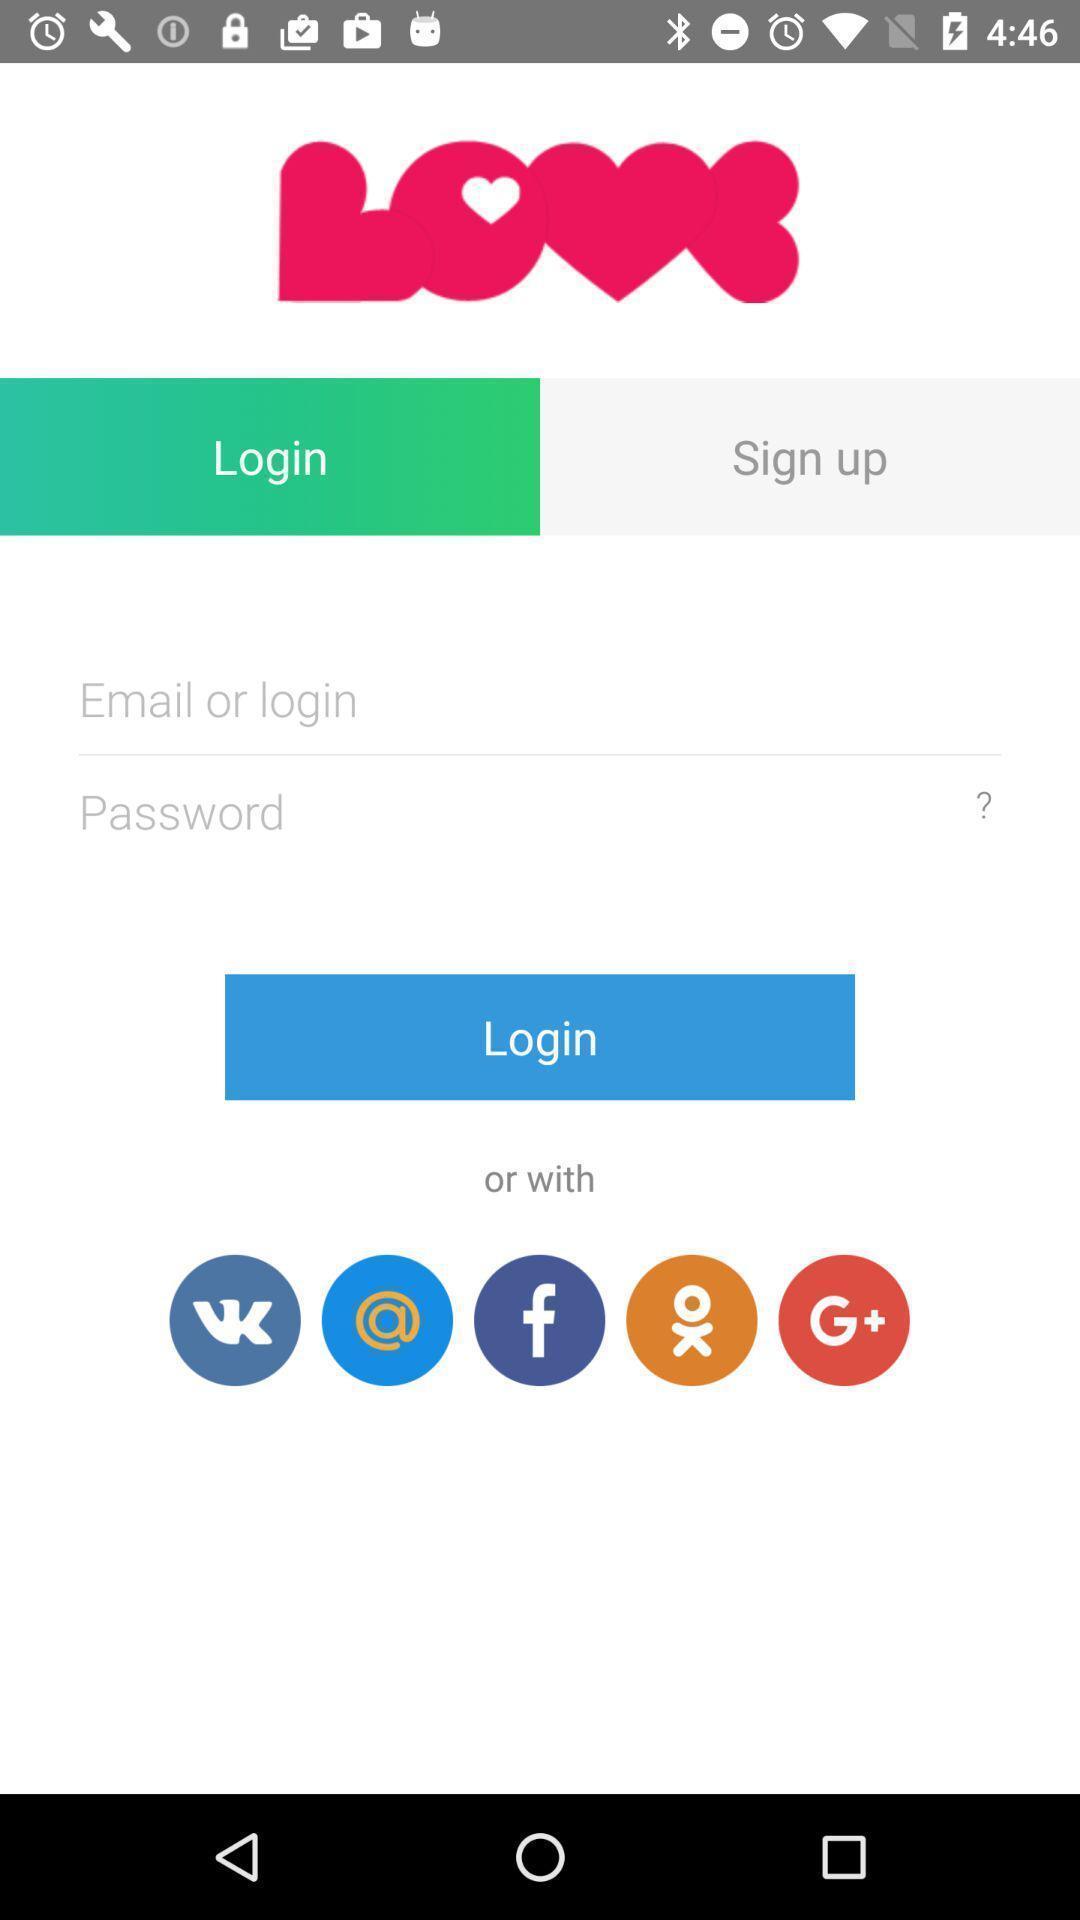What is the overall content of this screenshot? Login page. 